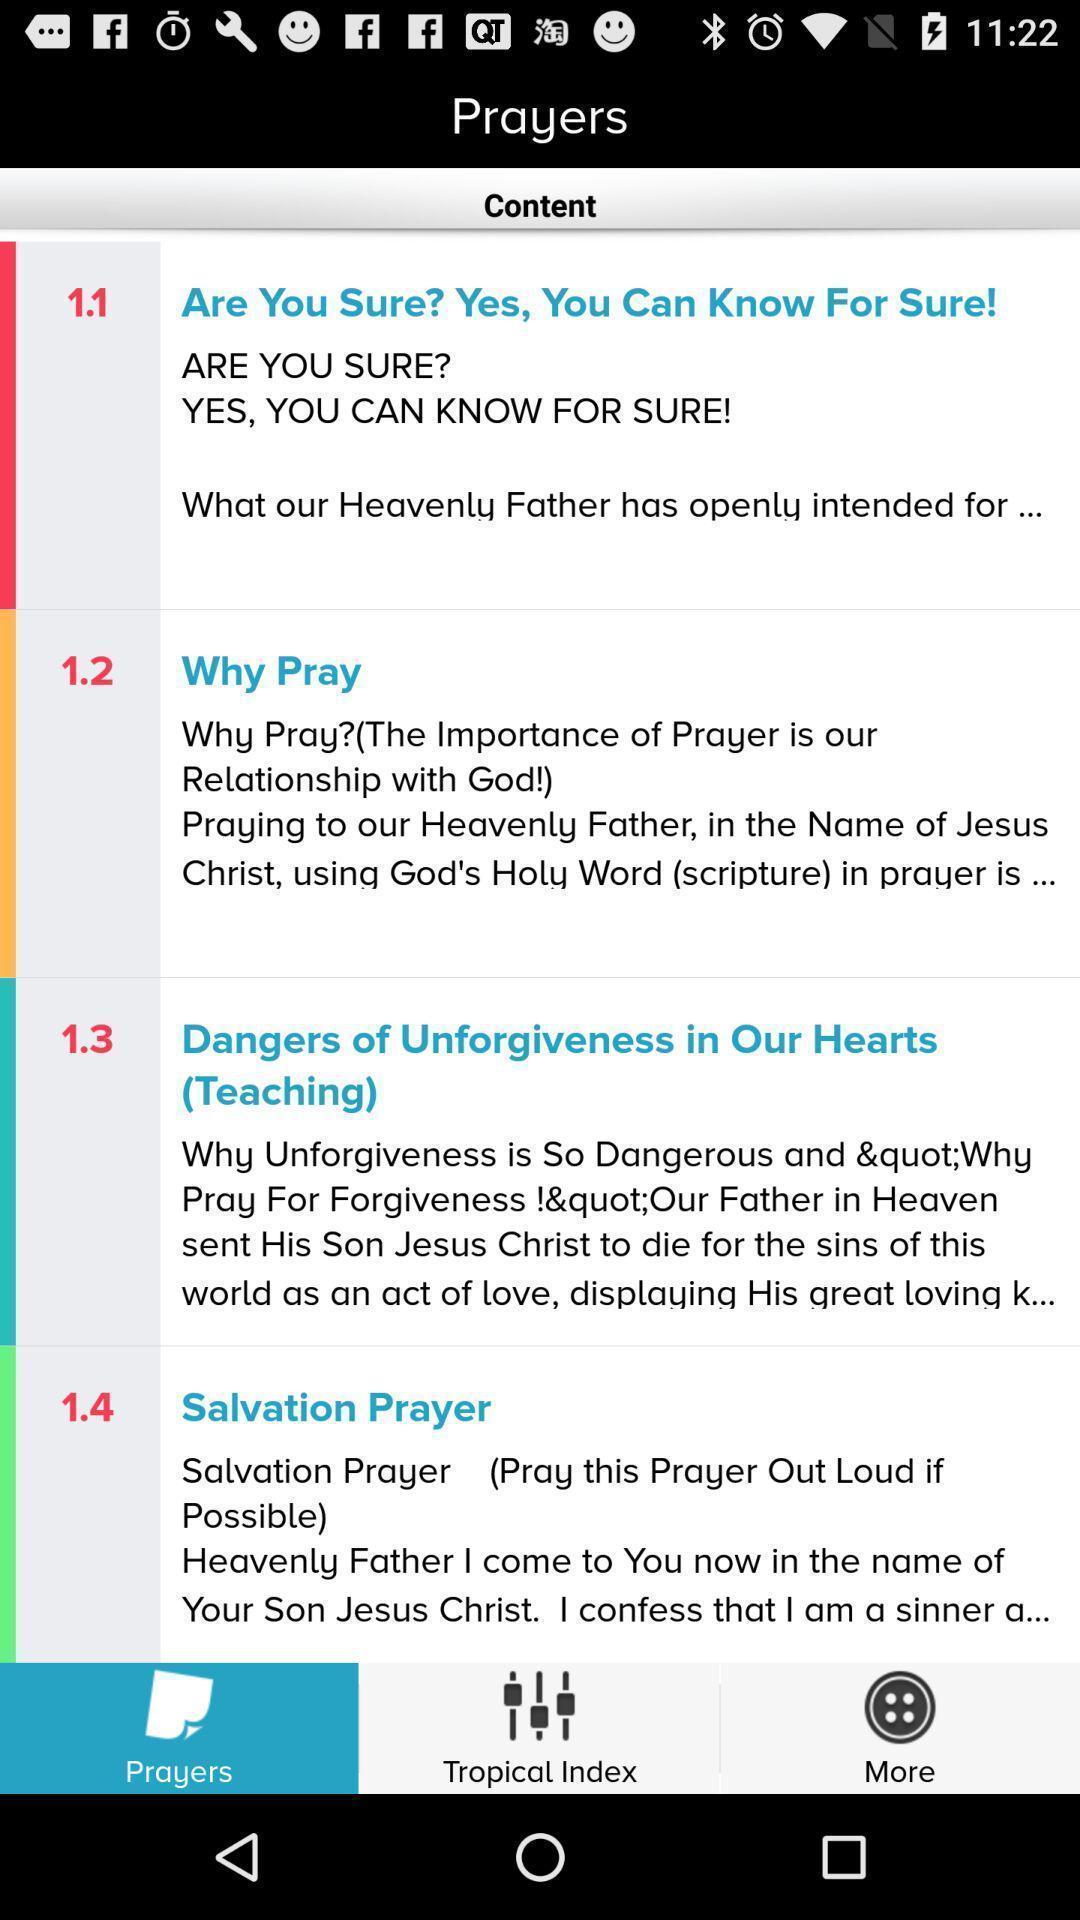Explain the elements present in this screenshot. Screen displaying a list of different prayer articles. 